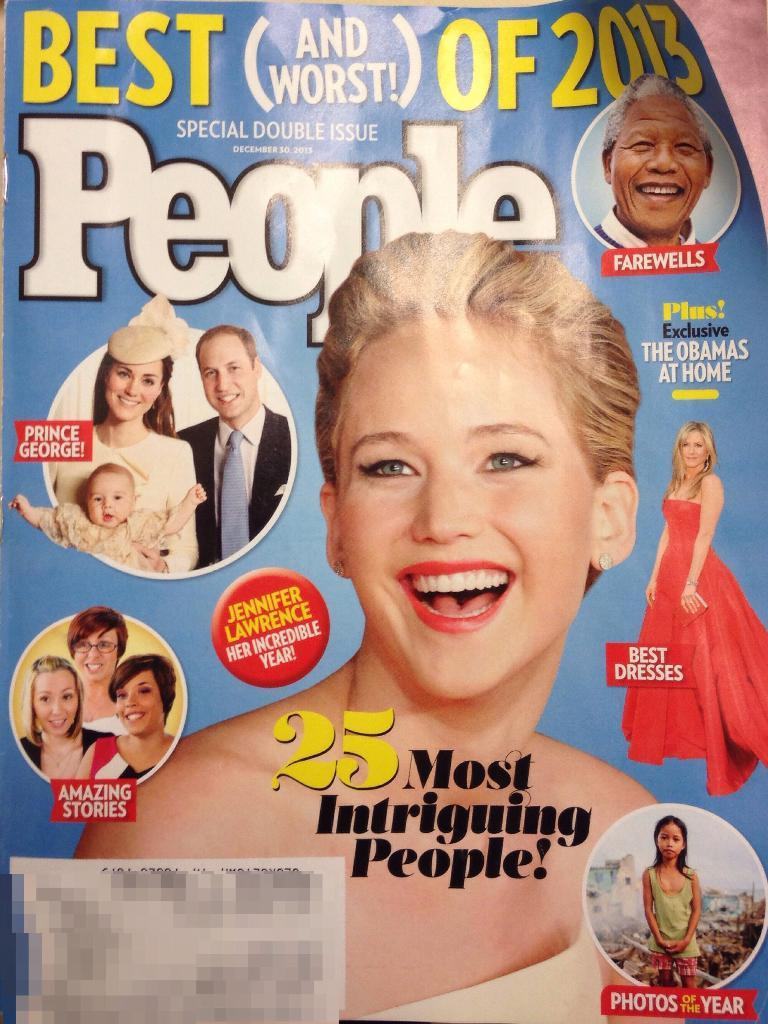What is the main subject of the image? The main subject of the image is a magazine cover. What can be seen on the front of the magazine cover? A girl is smiling on the front of the magazine cover. What phrase is written on the magazine cover? "Best People" is written on the magazine cover. How many crackers are visible on the magazine cover? There are no crackers present on the magazine cover; it features a smiling girl and the phrase "Best People." 